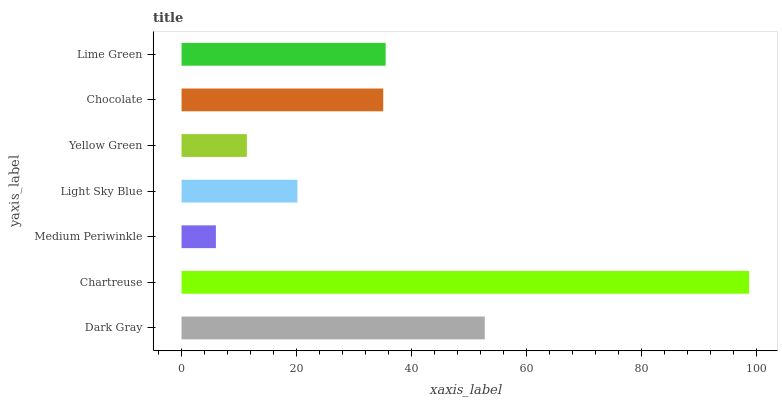Is Medium Periwinkle the minimum?
Answer yes or no. Yes. Is Chartreuse the maximum?
Answer yes or no. Yes. Is Chartreuse the minimum?
Answer yes or no. No. Is Medium Periwinkle the maximum?
Answer yes or no. No. Is Chartreuse greater than Medium Periwinkle?
Answer yes or no. Yes. Is Medium Periwinkle less than Chartreuse?
Answer yes or no. Yes. Is Medium Periwinkle greater than Chartreuse?
Answer yes or no. No. Is Chartreuse less than Medium Periwinkle?
Answer yes or no. No. Is Chocolate the high median?
Answer yes or no. Yes. Is Chocolate the low median?
Answer yes or no. Yes. Is Lime Green the high median?
Answer yes or no. No. Is Light Sky Blue the low median?
Answer yes or no. No. 